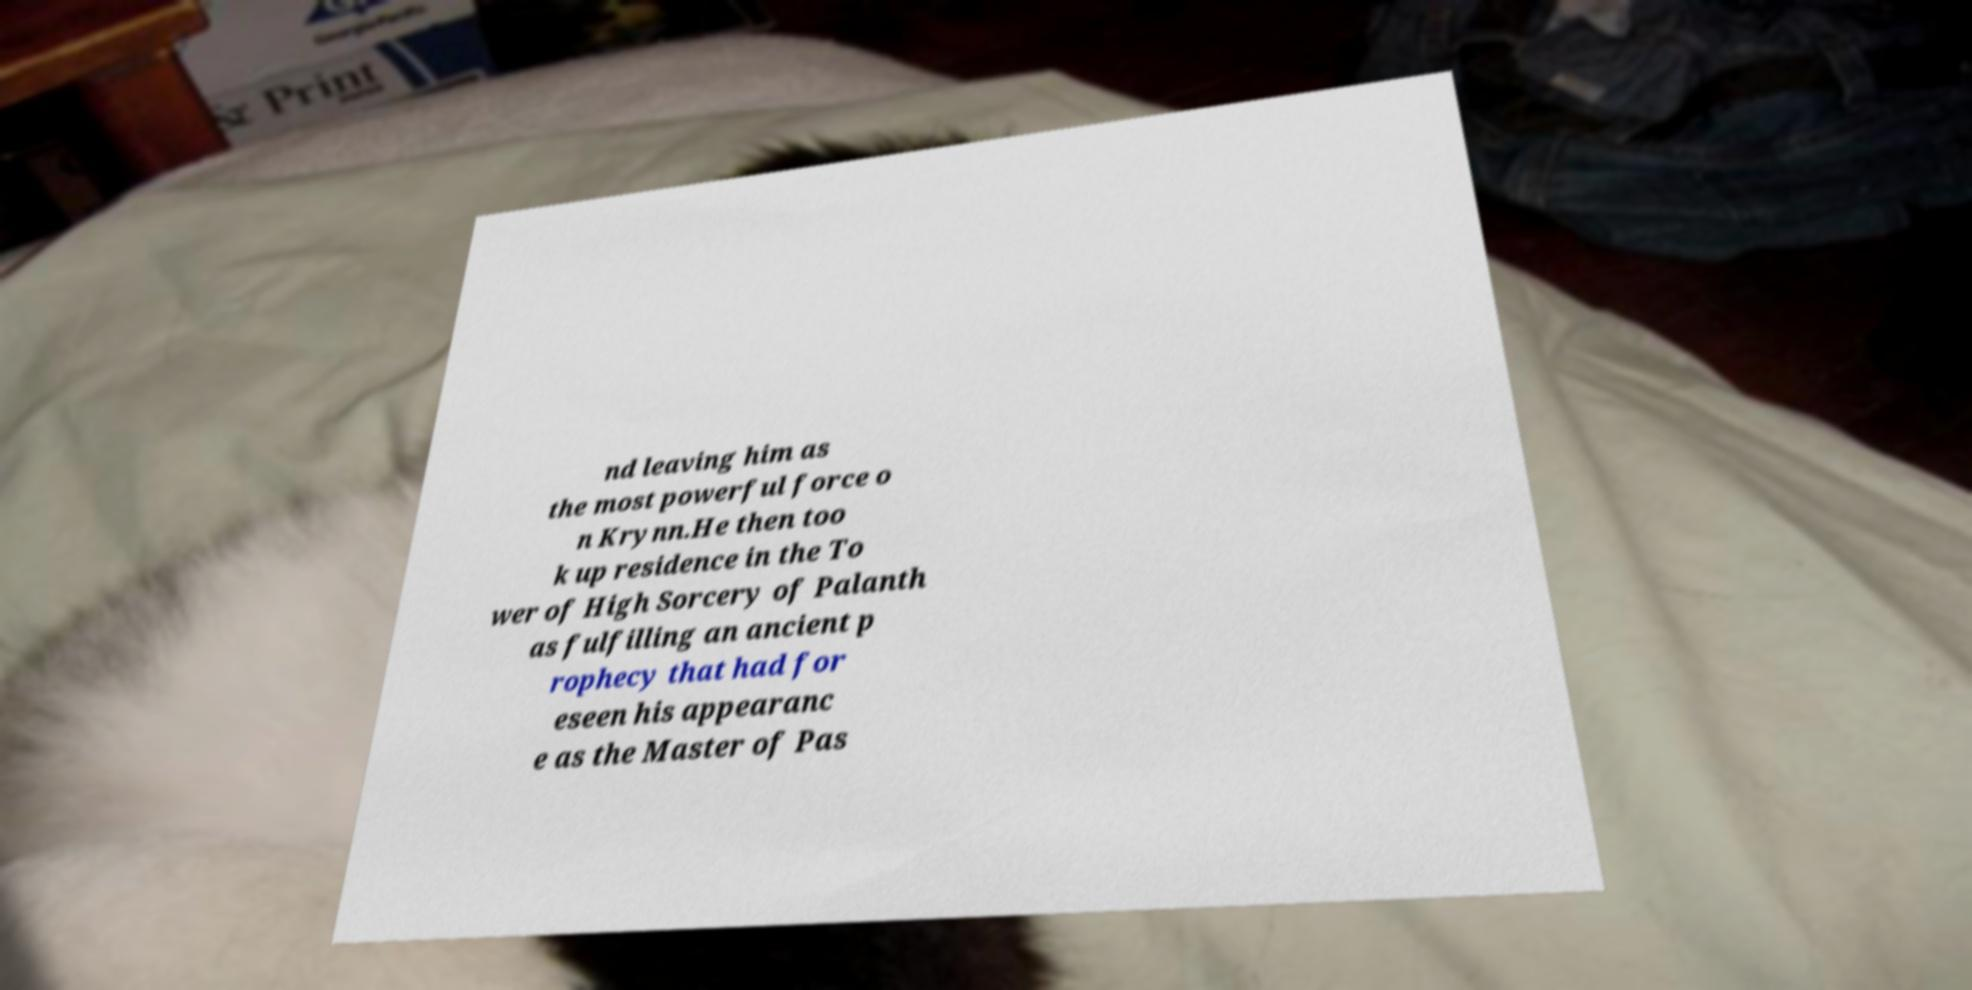Please read and relay the text visible in this image. What does it say? nd leaving him as the most powerful force o n Krynn.He then too k up residence in the To wer of High Sorcery of Palanth as fulfilling an ancient p rophecy that had for eseen his appearanc e as the Master of Pas 